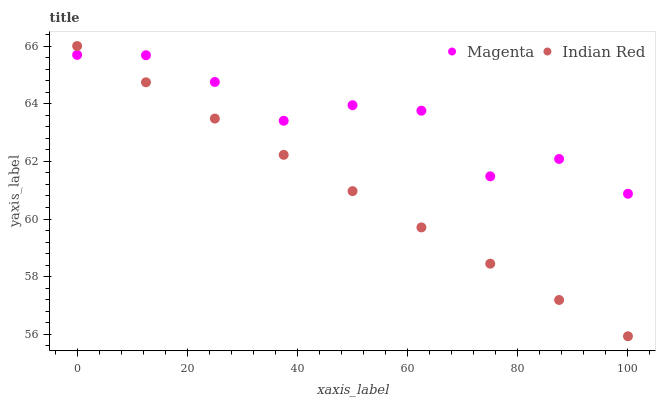Does Indian Red have the minimum area under the curve?
Answer yes or no. Yes. Does Magenta have the maximum area under the curve?
Answer yes or no. Yes. Does Indian Red have the maximum area under the curve?
Answer yes or no. No. Is Indian Red the smoothest?
Answer yes or no. Yes. Is Magenta the roughest?
Answer yes or no. Yes. Is Indian Red the roughest?
Answer yes or no. No. Does Indian Red have the lowest value?
Answer yes or no. Yes. Does Indian Red have the highest value?
Answer yes or no. Yes. Does Magenta intersect Indian Red?
Answer yes or no. Yes. Is Magenta less than Indian Red?
Answer yes or no. No. Is Magenta greater than Indian Red?
Answer yes or no. No. 